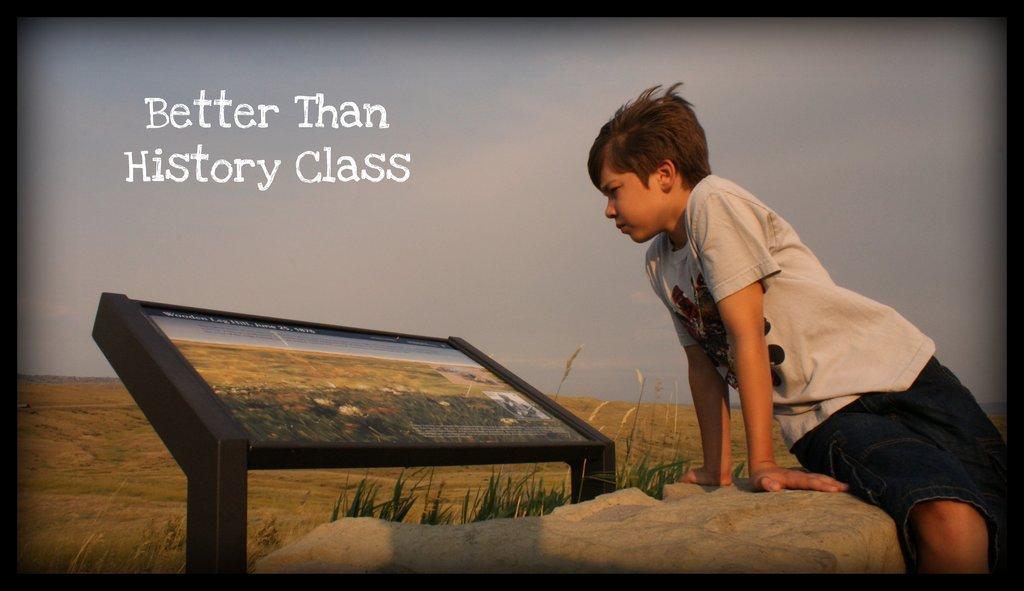Describe this image in one or two sentences. In this image I can see a person sitting. The person is wearing gray shirt, black color short. In front I can see a screen, grass in green color. Background sky is in gray and white color. 